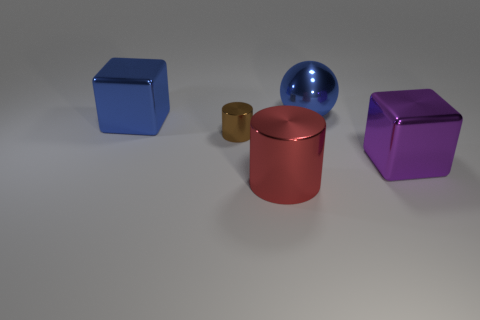Add 1 purple metallic cubes. How many objects exist? 6 Subtract all cylinders. How many objects are left? 3 Subtract 2 blocks. How many blocks are left? 0 Add 3 blue balls. How many blue balls are left? 4 Add 4 balls. How many balls exist? 5 Subtract 0 yellow spheres. How many objects are left? 5 Subtract all gray blocks. Subtract all gray cylinders. How many blocks are left? 2 Subtract all red cylinders. How many blue blocks are left? 1 Subtract all blue balls. Subtract all big blue things. How many objects are left? 2 